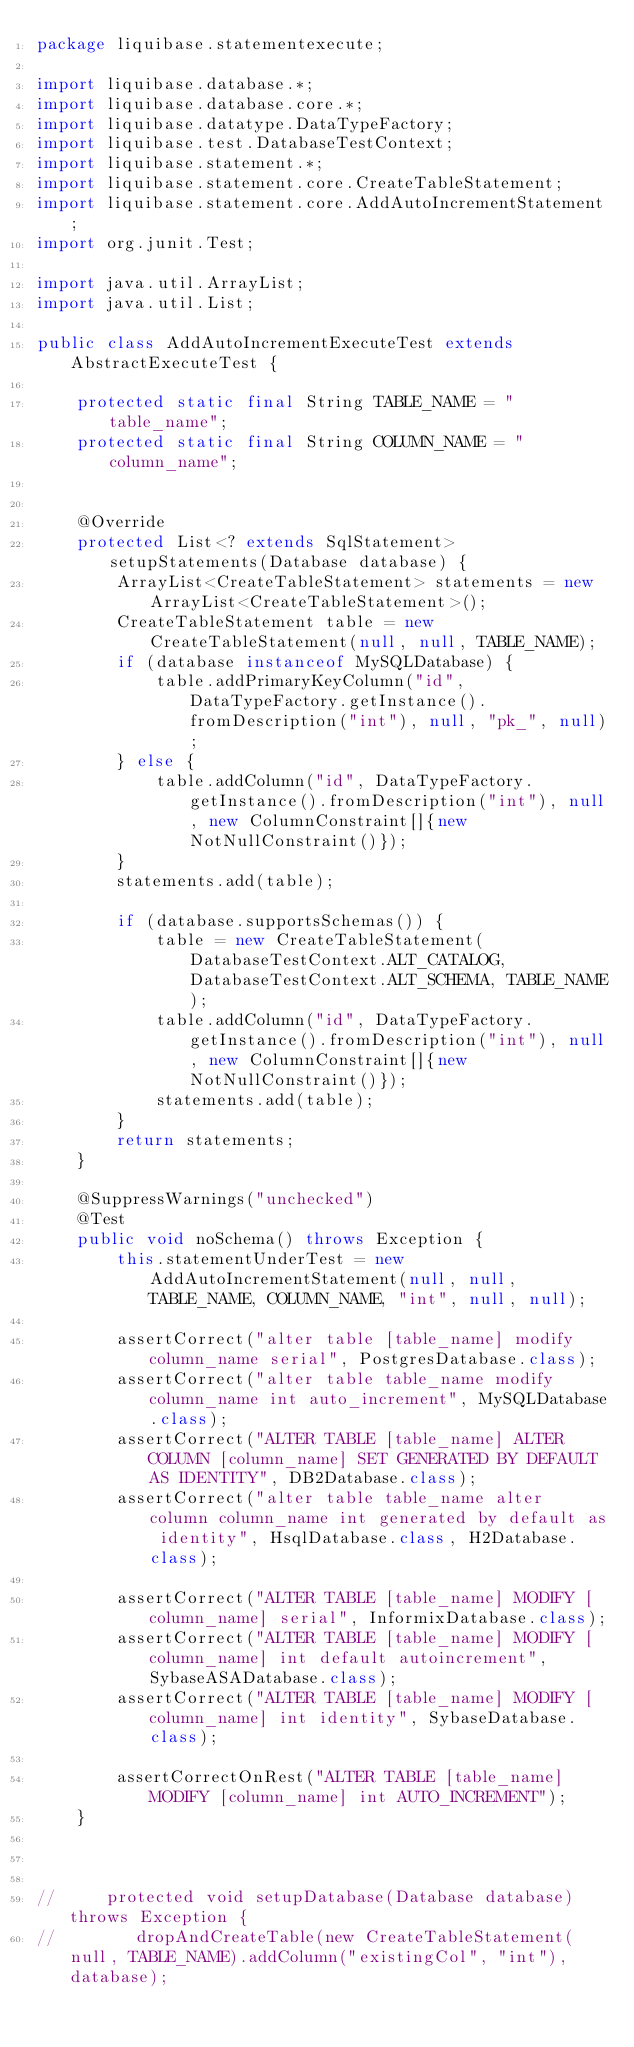Convert code to text. <code><loc_0><loc_0><loc_500><loc_500><_Java_>package liquibase.statementexecute;

import liquibase.database.*;
import liquibase.database.core.*;
import liquibase.datatype.DataTypeFactory;
import liquibase.test.DatabaseTestContext;
import liquibase.statement.*;
import liquibase.statement.core.CreateTableStatement;
import liquibase.statement.core.AddAutoIncrementStatement;
import org.junit.Test;

import java.util.ArrayList;
import java.util.List;

public class AddAutoIncrementExecuteTest extends AbstractExecuteTest {

    protected static final String TABLE_NAME = "table_name";
    protected static final String COLUMN_NAME = "column_name";


    @Override
    protected List<? extends SqlStatement> setupStatements(Database database) {
        ArrayList<CreateTableStatement> statements = new ArrayList<CreateTableStatement>();
        CreateTableStatement table = new CreateTableStatement(null, null, TABLE_NAME);
        if (database instanceof MySQLDatabase) {
            table.addPrimaryKeyColumn("id", DataTypeFactory.getInstance().fromDescription("int"), null, "pk_", null);
        } else {
            table.addColumn("id", DataTypeFactory.getInstance().fromDescription("int"), null, new ColumnConstraint[]{new NotNullConstraint()});
        }
        statements.add(table);

        if (database.supportsSchemas()) {
            table = new CreateTableStatement(DatabaseTestContext.ALT_CATALOG, DatabaseTestContext.ALT_SCHEMA, TABLE_NAME);
            table.addColumn("id", DataTypeFactory.getInstance().fromDescription("int"), null, new ColumnConstraint[]{new NotNullConstraint()});
            statements.add(table);
        }
        return statements;
    }

    @SuppressWarnings("unchecked")
    @Test
    public void noSchema() throws Exception {
        this.statementUnderTest = new AddAutoIncrementStatement(null, null, TABLE_NAME, COLUMN_NAME, "int", null, null);

        assertCorrect("alter table [table_name] modify column_name serial", PostgresDatabase.class);
        assertCorrect("alter table table_name modify column_name int auto_increment", MySQLDatabase.class);
        assertCorrect("ALTER TABLE [table_name] ALTER COLUMN [column_name] SET GENERATED BY DEFAULT AS IDENTITY", DB2Database.class);
        assertCorrect("alter table table_name alter column column_name int generated by default as identity", HsqlDatabase.class, H2Database.class);

        assertCorrect("ALTER TABLE [table_name] MODIFY [column_name] serial", InformixDatabase.class);
        assertCorrect("ALTER TABLE [table_name] MODIFY [column_name] int default autoincrement", SybaseASADatabase.class);
        assertCorrect("ALTER TABLE [table_name] MODIFY [column_name] int identity", SybaseDatabase.class);

        assertCorrectOnRest("ALTER TABLE [table_name] MODIFY [column_name] int AUTO_INCREMENT");
    }



//     protected void setupDatabase(Database database) throws Exception {
//        dropAndCreateTable(new CreateTableStatement(null, TABLE_NAME).addColumn("existingCol", "int"), database);</code> 